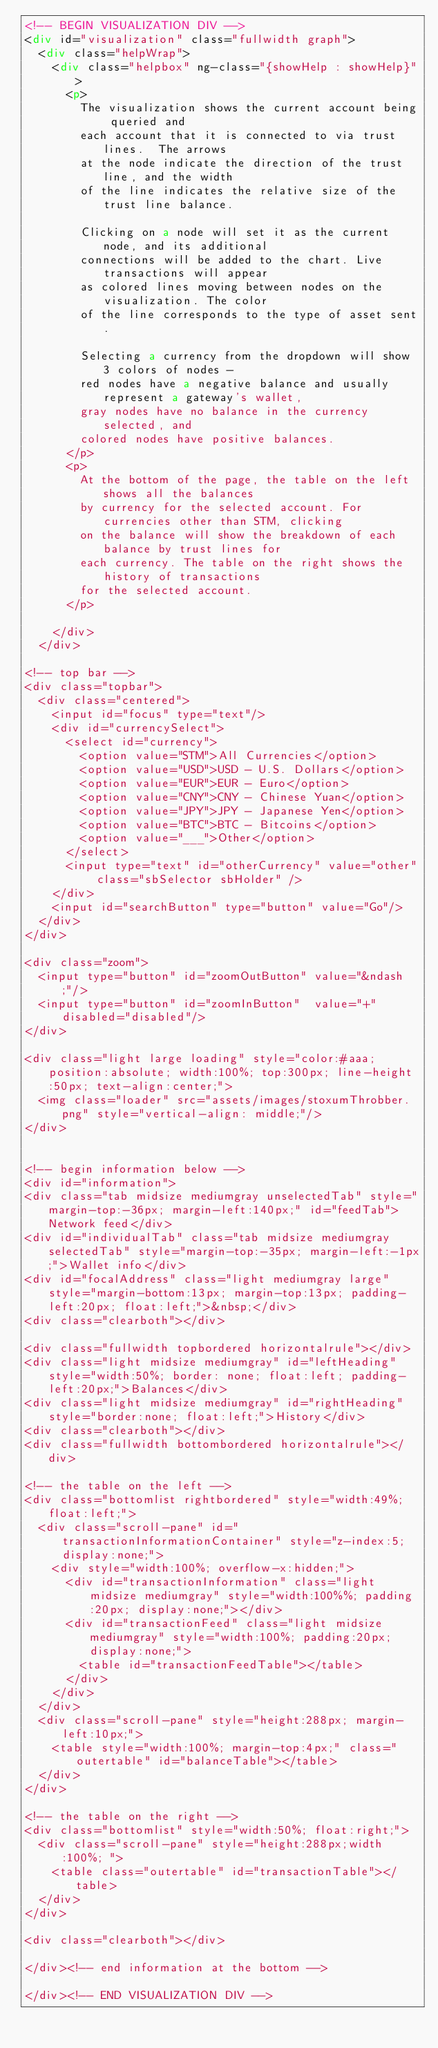Convert code to text. <code><loc_0><loc_0><loc_500><loc_500><_HTML_><!-- BEGIN VISUALIZATION DIV -->
<div id="visualization" class="fullwidth graph">
  <div class="helpWrap">
    <div class="helpbox" ng-class="{showHelp : showHelp}">
      <p>
        The visualization shows the current account being queried and
        each account that it is connected to via trust lines.  The arrows
        at the node indicate the direction of the trust line, and the width
        of the line indicates the relative size of the trust line balance.

        Clicking on a node will set it as the current node, and its additional
        connections will be added to the chart. Live transactions will appear
        as colored lines moving between nodes on the visualization. The color
        of the line corresponds to the type of asset sent.

        Selecting a currency from the dropdown will show 3 colors of nodes -
        red nodes have a negative balance and usually represent a gateway's wallet,
        gray nodes have no balance in the currency selected, and
        colored nodes have positive balances.
      </p>
      <p>
        At the bottom of the page, the table on the left shows all the balances
        by currency for the selected account. For currencies other than STM, clicking
        on the balance will show the breakdown of each balance by trust lines for
        each currency. The table on the right shows the history of transactions
        for the selected account.
      </p>

    </div>
  </div>

<!-- top bar -->
<div class="topbar">
  <div class="centered">
    <input id="focus" type="text"/>
    <div id="currencySelect">
      <select id="currency">
        <option value="STM">All Currencies</option>
        <option value="USD">USD - U.S. Dollars</option>
        <option value="EUR">EUR - Euro</option>
        <option value="CNY">CNY - Chinese Yuan</option>
        <option value="JPY">JPY - Japanese Yen</option>
        <option value="BTC">BTC - Bitcoins</option>
        <option value="___">Other</option>
      </select>
      <input type="text" id="otherCurrency" value="other" class="sbSelector sbHolder" />
    </div>
    <input id="searchButton" type="button" value="Go"/>
  </div>
</div>

<div class="zoom">
  <input type="button" id="zoomOutButton" value="&ndash;"/>
  <input type="button" id="zoomInButton"  value="+" disabled="disabled"/>
</div>

<div class="light large loading" style="color:#aaa; position:absolute; width:100%; top:300px; line-height:50px; text-align:center;">
  <img class="loader" src="assets/images/stoxumThrobber.png" style="vertical-align: middle;"/>
</div>


<!-- begin information below -->
<div id="information">
<div class="tab midsize mediumgray unselectedTab" style="margin-top:-36px; margin-left:140px;" id="feedTab">Network feed</div>
<div id="individualTab" class="tab midsize mediumgray selectedTab" style="margin-top:-35px; margin-left:-1px;">Wallet info</div>
<div id="focalAddress" class="light mediumgray large" style="margin-bottom:13px; margin-top:13px; padding-left:20px; float:left;">&nbsp;</div>
<div class="clearboth"></div>

<div class="fullwidth topbordered horizontalrule"></div>
<div class="light midsize mediumgray" id="leftHeading" style="width:50%; border: none; float:left; padding-left:20px;">Balances</div>
<div class="light midsize mediumgray" id="rightHeading" style="border:none; float:left;">History</div>
<div class="clearboth"></div>
<div class="fullwidth bottombordered horizontalrule"></div>

<!-- the table on the left -->
<div class="bottomlist rightbordered" style="width:49%; float:left;">
  <div class="scroll-pane" id="transactionInformationContainer" style="z-index:5; display:none;">
    <div style="width:100%; overflow-x:hidden;">
      <div id="transactionInformation" class="light midsize mediumgray" style="width:100%%; padding:20px; display:none;"></div>
      <div id="transactionFeed" class="light midsize mediumgray" style="width:100%; padding:20px; display:none;">
        <table id="transactionFeedTable"></table>
      </div>
    </div>
  </div>
  <div class="scroll-pane" style="height:288px; margin-left:10px;">
    <table style="width:100%; margin-top:4px;" class="outertable" id="balanceTable"></table>
  </div>
</div>

<!-- the table on the right -->
<div class="bottomlist" style="width:50%; float:right;">
  <div class="scroll-pane" style="height:288px;width:100%; ">
    <table class="outertable" id="transactionTable"></table>
  </div>
</div>

<div class="clearboth"></div>

</div><!-- end information at the bottom -->

</div><!-- END VISUALIZATION DIV -->
</code> 